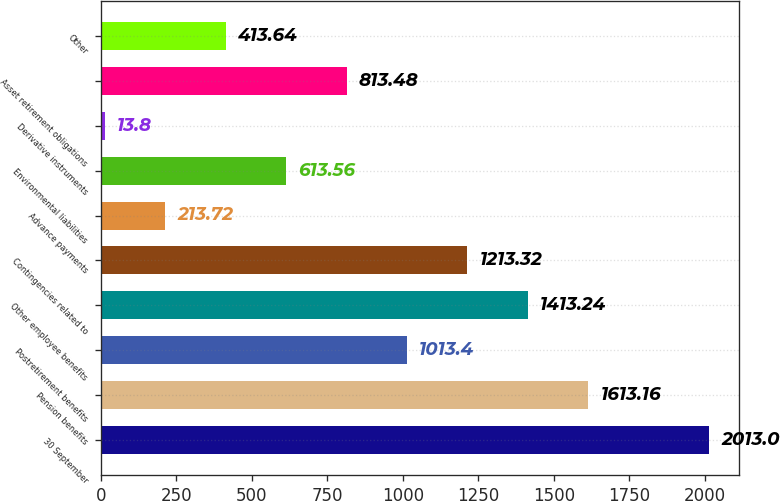<chart> <loc_0><loc_0><loc_500><loc_500><bar_chart><fcel>30 September<fcel>Pension benefits<fcel>Postretirement benefits<fcel>Other employee benefits<fcel>Contingencies related to<fcel>Advance payments<fcel>Environmental liabilities<fcel>Derivative instruments<fcel>Asset retirement obligations<fcel>Other<nl><fcel>2013<fcel>1613.16<fcel>1013.4<fcel>1413.24<fcel>1213.32<fcel>213.72<fcel>613.56<fcel>13.8<fcel>813.48<fcel>413.64<nl></chart> 